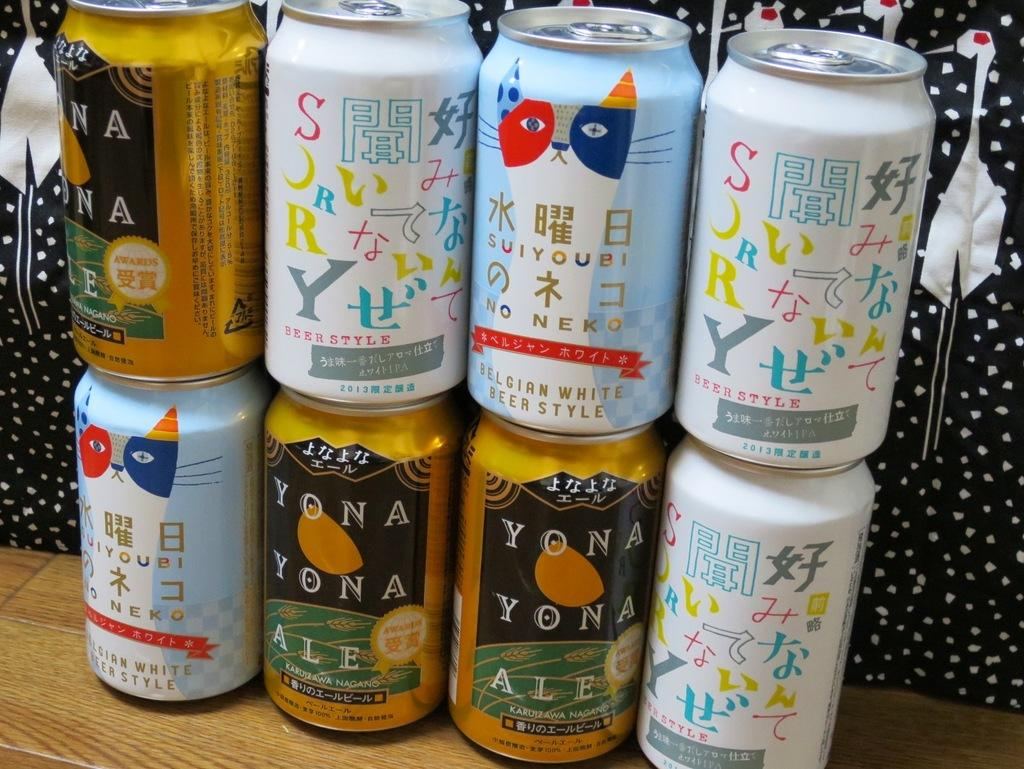Provide a one-sentence caption for the provided image. a set of canned drinks including Yona Yona Ale. 